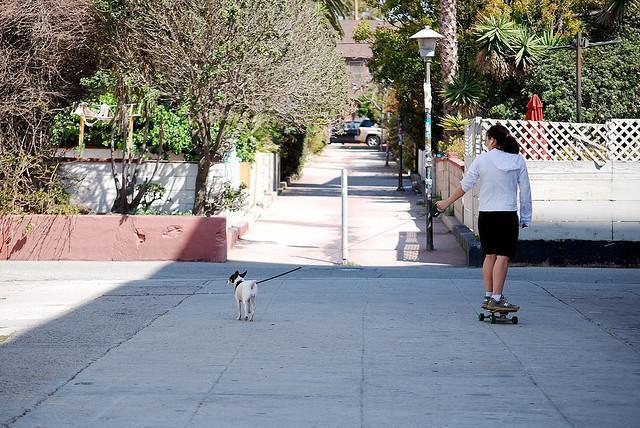How many people are visible?
Give a very brief answer. 1. How many giraffes are in the image?
Give a very brief answer. 0. 